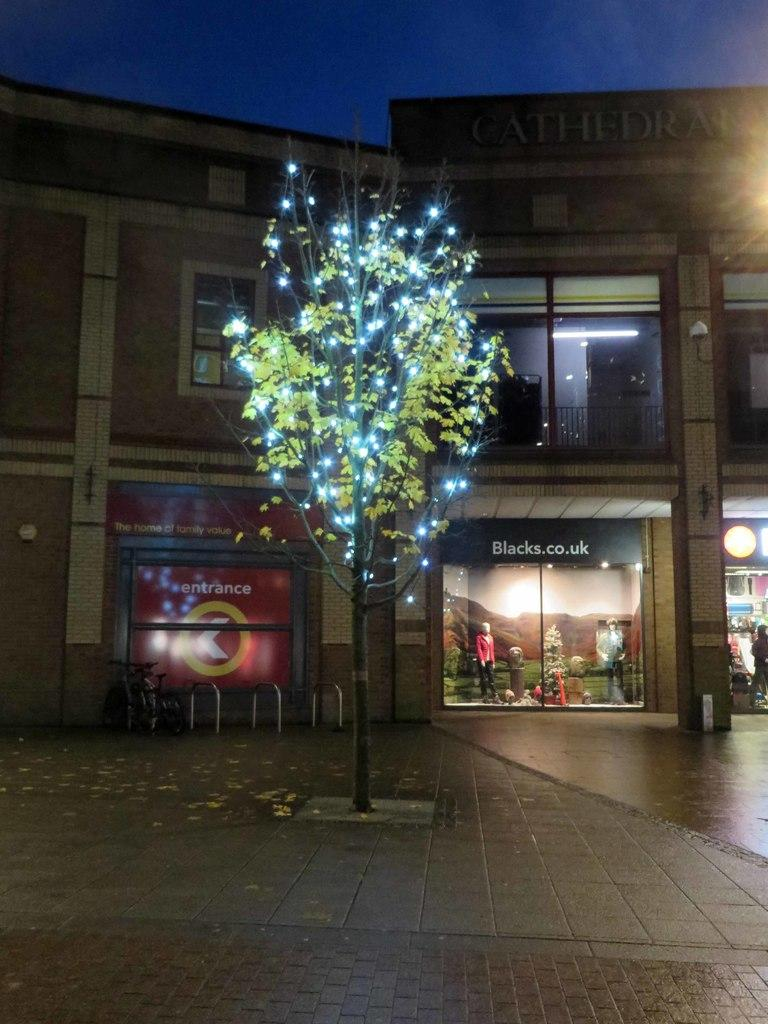What is the main feature of the tree in the image? The tree in the image has lights on it. What can be seen in the background of the image? There is a building, a person, and mannequins in the background of the image. What is visible in the sky in the image? The sky is visible in the background of the image. What is the person in the image doing during their journey? There is no indication of a journey in the image, as it only shows a tree with lights and other elements in the background. 